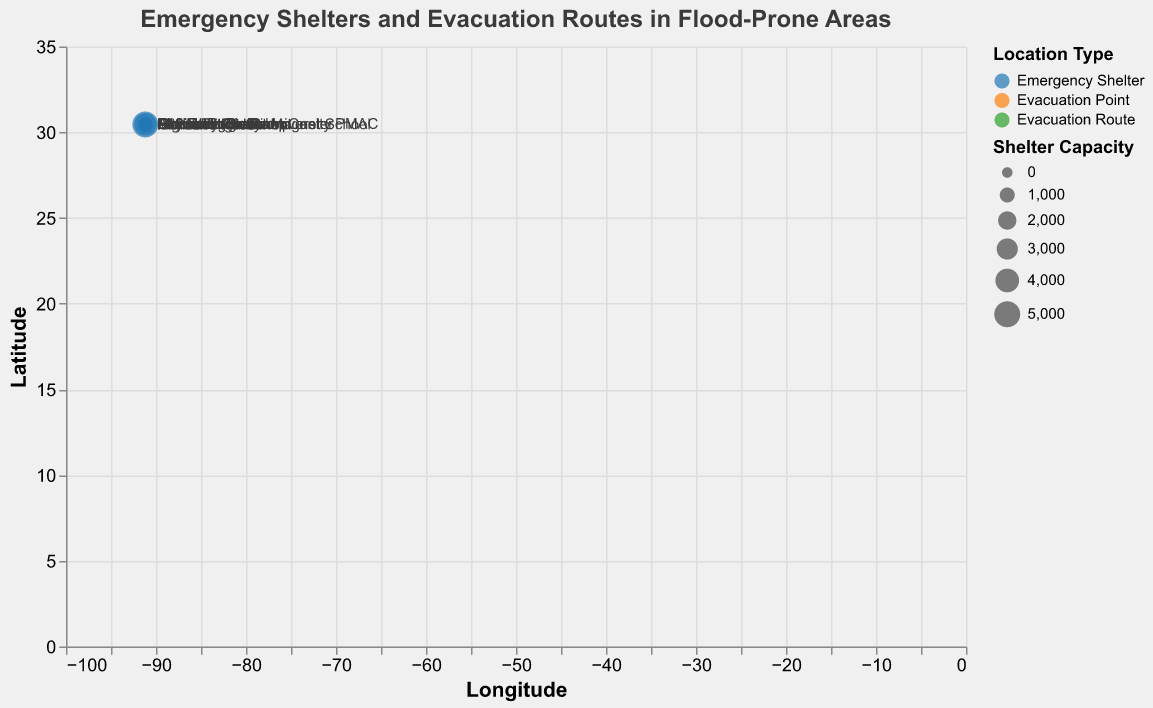What is the title of the figure? The title of the figure is usually displayed at the top and provides a brief description of what the figure represents.
Answer: Emergency Shelters and Evacuation Routes in Flood-Prone Areas What are the different types of locations shown in the figure? The figure uses different colors to represent the types of locations, displayed in the legend.
Answer: Emergency Shelter, Evacuation Point, Evacuation Route Which emergency shelter has the highest capacity? To find this, look at the size of the circles representing emergency shelters and check the tooltip or legend for capacity details.
Answer: Baton Rouge River Center Which evacuation route has the highest elevation? Check the green circles (evacuation routes) and refer to the tooltip or elevation data to find the highest value.
Answer: Highland Road How many emergency shelters are plotted in the figure? Count the blue circles representing emergency shelters in the figure.
Answer: 4 What is the average elevation of the emergency shelters? Identify the elevations of all emergency shelters and calculate the average: (6 + 8 + 10 + 12) / 4 = 9.
Answer: 9 meters Which emergency shelter is closest to an evacuation route? Visually inspect the map and look for the smallest distance between blue (shelter) and green (route) circles. McKinley Middle Magnet School is close to I-10 West On-Ramp.
Answer: McKinley Middle Magnet School What is the relative position of City Hall to Central High School in terms of latitude and longitude? Compare their latitude and longitude coordinates to determine their positions. City Hall is southwest of Central High School.
Answer: Southwest Which location overall has the lowest elevation? Check the elevation values of all locations and find the smallest one.
Answer: I-10 West On-Ramp Are there more evacuation routes or emergency shelters shown in the figure? Count the total number of green circles (evacuation routes) and blue circles (emergency shelters) and compare them.
Answer: More evacuation routes 